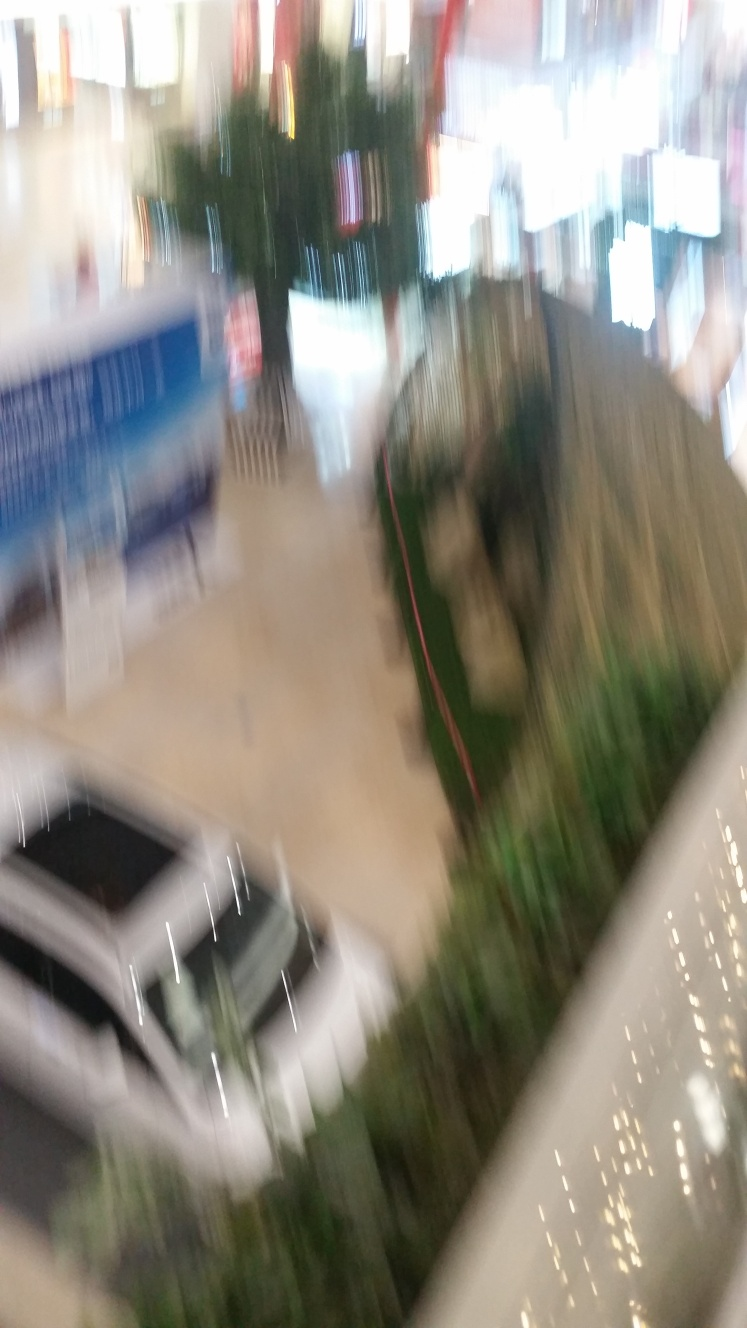Can you describe any discernible features in the image despite the poor quality? Despite the poor quality, one can perceive blurred outlines of what appears to be a car, indoor plants, and some indistinct backlit signage, suggesting an indoor setting possibly within a shopping center or exhibition hall. Is there anything about this image that provides clues to where it might have been taken? While details are scarce due to the blur, the presence of signage, the car, and the commercial ambiance suggest that the photo could have been taken inside a mall or a similar locale that hosts events or displays. 